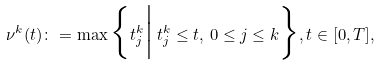Convert formula to latex. <formula><loc_0><loc_0><loc_500><loc_500>\nu ^ { k } ( t ) \colon = \max \Big \{ t ^ { k } _ { j } \Big | \, t ^ { k } _ { j } \leq t , \, 0 \leq j \leq k \Big \} , t \in [ 0 , T ] ,</formula> 